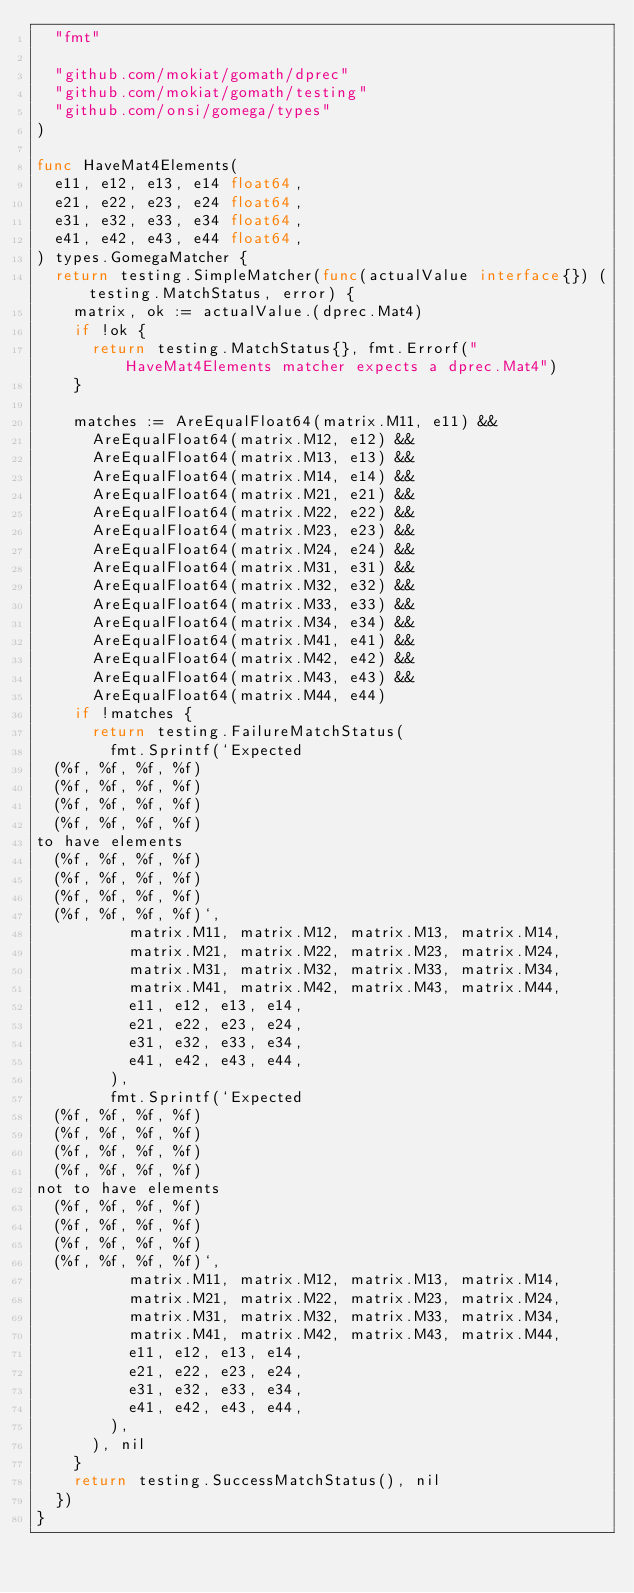<code> <loc_0><loc_0><loc_500><loc_500><_Go_>	"fmt"

	"github.com/mokiat/gomath/dprec"
	"github.com/mokiat/gomath/testing"
	"github.com/onsi/gomega/types"
)

func HaveMat4Elements(
	e11, e12, e13, e14 float64,
	e21, e22, e23, e24 float64,
	e31, e32, e33, e34 float64,
	e41, e42, e43, e44 float64,
) types.GomegaMatcher {
	return testing.SimpleMatcher(func(actualValue interface{}) (testing.MatchStatus, error) {
		matrix, ok := actualValue.(dprec.Mat4)
		if !ok {
			return testing.MatchStatus{}, fmt.Errorf("HaveMat4Elements matcher expects a dprec.Mat4")
		}

		matches := AreEqualFloat64(matrix.M11, e11) &&
			AreEqualFloat64(matrix.M12, e12) &&
			AreEqualFloat64(matrix.M13, e13) &&
			AreEqualFloat64(matrix.M14, e14) &&
			AreEqualFloat64(matrix.M21, e21) &&
			AreEqualFloat64(matrix.M22, e22) &&
			AreEqualFloat64(matrix.M23, e23) &&
			AreEqualFloat64(matrix.M24, e24) &&
			AreEqualFloat64(matrix.M31, e31) &&
			AreEqualFloat64(matrix.M32, e32) &&
			AreEqualFloat64(matrix.M33, e33) &&
			AreEqualFloat64(matrix.M34, e34) &&
			AreEqualFloat64(matrix.M41, e41) &&
			AreEqualFloat64(matrix.M42, e42) &&
			AreEqualFloat64(matrix.M43, e43) &&
			AreEqualFloat64(matrix.M44, e44)
		if !matches {
			return testing.FailureMatchStatus(
				fmt.Sprintf(`Expected
	(%f, %f, %f, %f)
	(%f, %f, %f, %f)
	(%f, %f, %f, %f)
	(%f, %f, %f, %f)					
to have elements
	(%f, %f, %f, %f)
	(%f, %f, %f, %f)
	(%f, %f, %f, %f)
	(%f, %f, %f, %f)`,
					matrix.M11, matrix.M12, matrix.M13, matrix.M14,
					matrix.M21, matrix.M22, matrix.M23, matrix.M24,
					matrix.M31, matrix.M32, matrix.M33, matrix.M34,
					matrix.M41, matrix.M42, matrix.M43, matrix.M44,
					e11, e12, e13, e14,
					e21, e22, e23, e24,
					e31, e32, e33, e34,
					e41, e42, e43, e44,
				),
				fmt.Sprintf(`Expected
	(%f, %f, %f, %f)
	(%f, %f, %f, %f)
	(%f, %f, %f, %f)
	(%f, %f, %f, %f)					
not to have elements
	(%f, %f, %f, %f)
	(%f, %f, %f, %f)
	(%f, %f, %f, %f)
	(%f, %f, %f, %f)`,
					matrix.M11, matrix.M12, matrix.M13, matrix.M14,
					matrix.M21, matrix.M22, matrix.M23, matrix.M24,
					matrix.M31, matrix.M32, matrix.M33, matrix.M34,
					matrix.M41, matrix.M42, matrix.M43, matrix.M44,
					e11, e12, e13, e14,
					e21, e22, e23, e24,
					e31, e32, e33, e34,
					e41, e42, e43, e44,
				),
			), nil
		}
		return testing.SuccessMatchStatus(), nil
	})
}
</code> 